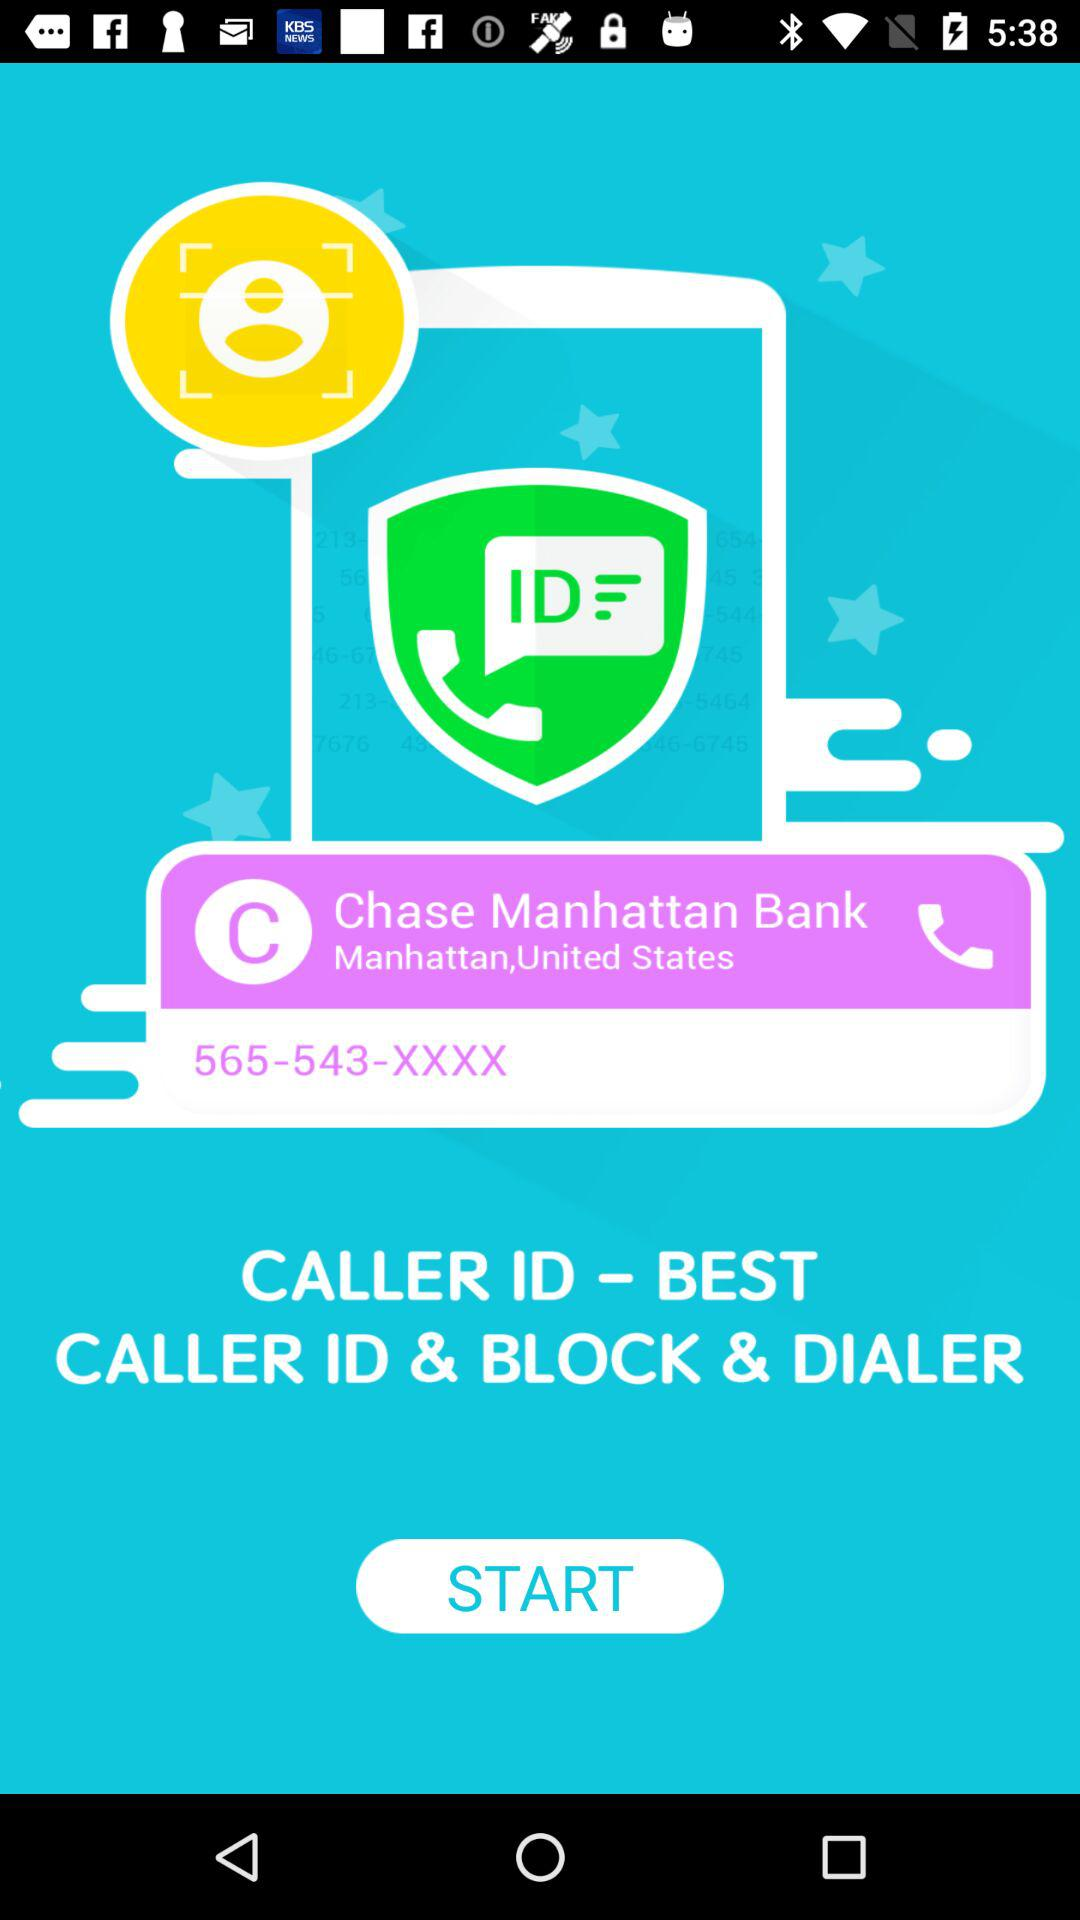What is the name of the bank? The name of the bank is "Chase Manhattan Bank". 